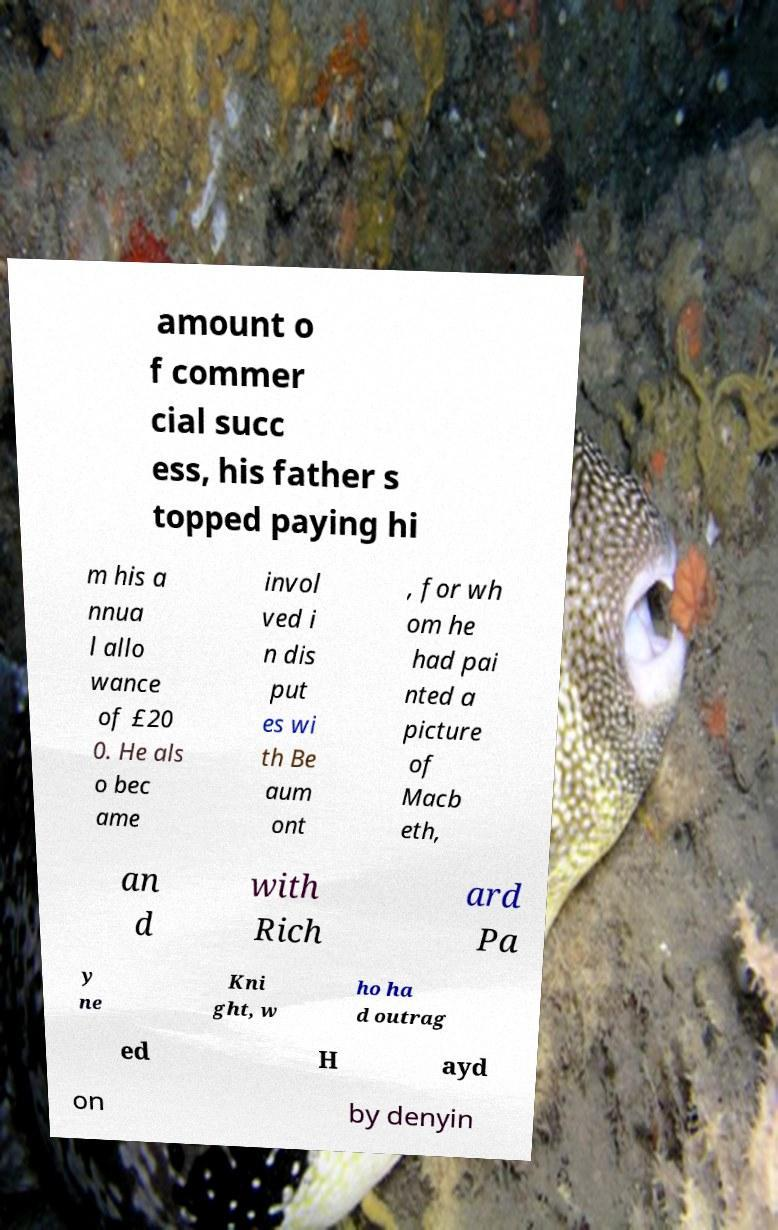Can you read and provide the text displayed in the image?This photo seems to have some interesting text. Can you extract and type it out for me? amount o f commer cial succ ess, his father s topped paying hi m his a nnua l allo wance of £20 0. He als o bec ame invol ved i n dis put es wi th Be aum ont , for wh om he had pai nted a picture of Macb eth, an d with Rich ard Pa y ne Kni ght, w ho ha d outrag ed H ayd on by denyin 